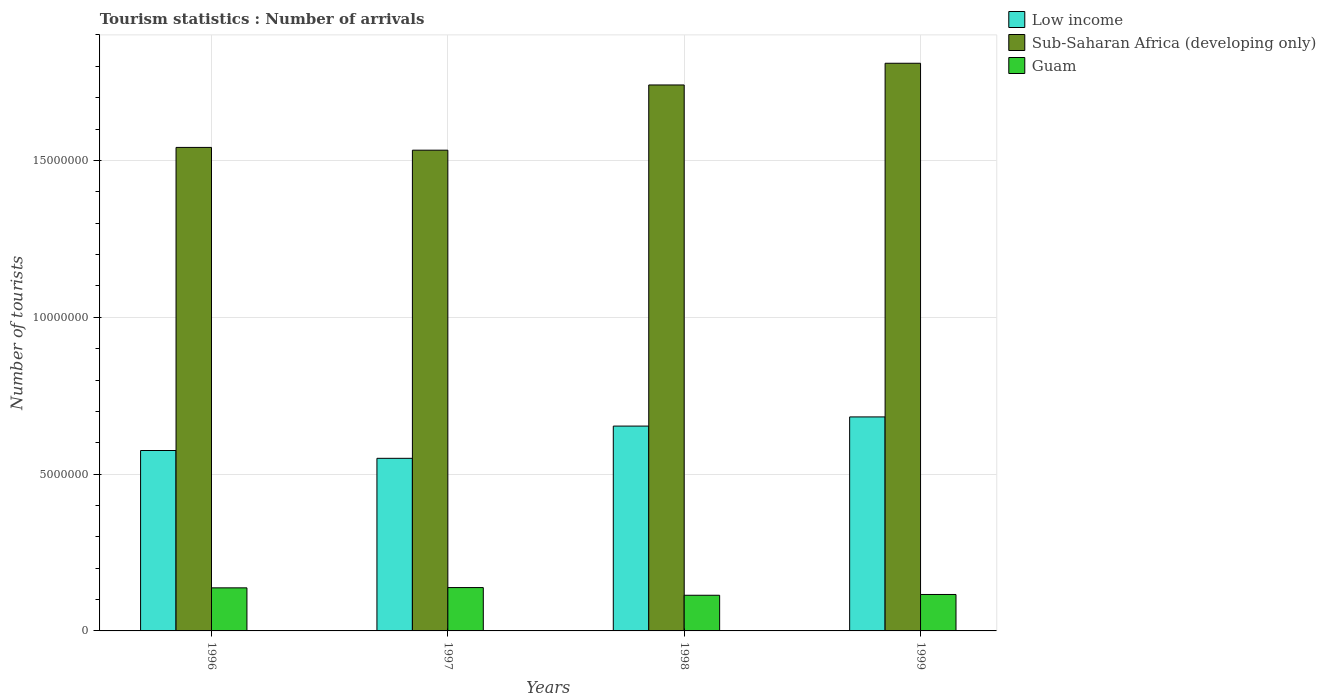How many groups of bars are there?
Make the answer very short. 4. Are the number of bars on each tick of the X-axis equal?
Provide a succinct answer. Yes. How many bars are there on the 3rd tick from the left?
Ensure brevity in your answer.  3. How many bars are there on the 4th tick from the right?
Your response must be concise. 3. What is the number of tourist arrivals in Guam in 1997?
Your answer should be compact. 1.38e+06. Across all years, what is the maximum number of tourist arrivals in Guam?
Your answer should be very brief. 1.38e+06. Across all years, what is the minimum number of tourist arrivals in Guam?
Offer a terse response. 1.14e+06. In which year was the number of tourist arrivals in Guam maximum?
Provide a succinct answer. 1997. In which year was the number of tourist arrivals in Low income minimum?
Your answer should be very brief. 1997. What is the total number of tourist arrivals in Low income in the graph?
Your response must be concise. 2.46e+07. What is the difference between the number of tourist arrivals in Guam in 1996 and that in 1999?
Keep it short and to the point. 2.11e+05. What is the difference between the number of tourist arrivals in Low income in 1997 and the number of tourist arrivals in Guam in 1996?
Your answer should be very brief. 4.13e+06. What is the average number of tourist arrivals in Guam per year?
Ensure brevity in your answer.  1.26e+06. In the year 1998, what is the difference between the number of tourist arrivals in Low income and number of tourist arrivals in Sub-Saharan Africa (developing only)?
Your response must be concise. -1.09e+07. In how many years, is the number of tourist arrivals in Low income greater than 16000000?
Your answer should be very brief. 0. What is the ratio of the number of tourist arrivals in Sub-Saharan Africa (developing only) in 1996 to that in 1999?
Make the answer very short. 0.85. Is the number of tourist arrivals in Guam in 1998 less than that in 1999?
Your response must be concise. Yes. Is the difference between the number of tourist arrivals in Low income in 1996 and 1997 greater than the difference between the number of tourist arrivals in Sub-Saharan Africa (developing only) in 1996 and 1997?
Give a very brief answer. Yes. What is the difference between the highest and the second highest number of tourist arrivals in Low income?
Make the answer very short. 2.92e+05. What is the difference between the highest and the lowest number of tourist arrivals in Sub-Saharan Africa (developing only)?
Your answer should be compact. 2.77e+06. What does the 3rd bar from the left in 1996 represents?
Provide a succinct answer. Guam. What does the 2nd bar from the right in 1997 represents?
Make the answer very short. Sub-Saharan Africa (developing only). Is it the case that in every year, the sum of the number of tourist arrivals in Guam and number of tourist arrivals in Sub-Saharan Africa (developing only) is greater than the number of tourist arrivals in Low income?
Offer a very short reply. Yes. How many bars are there?
Your answer should be compact. 12. Are all the bars in the graph horizontal?
Give a very brief answer. No. How many years are there in the graph?
Provide a succinct answer. 4. What is the difference between two consecutive major ticks on the Y-axis?
Your response must be concise. 5.00e+06. Does the graph contain grids?
Your response must be concise. Yes. How many legend labels are there?
Provide a short and direct response. 3. What is the title of the graph?
Offer a very short reply. Tourism statistics : Number of arrivals. Does "Hungary" appear as one of the legend labels in the graph?
Ensure brevity in your answer.  No. What is the label or title of the X-axis?
Provide a succinct answer. Years. What is the label or title of the Y-axis?
Make the answer very short. Number of tourists. What is the Number of tourists in Low income in 1996?
Offer a terse response. 5.75e+06. What is the Number of tourists of Sub-Saharan Africa (developing only) in 1996?
Make the answer very short. 1.54e+07. What is the Number of tourists in Guam in 1996?
Provide a short and direct response. 1.37e+06. What is the Number of tourists in Low income in 1997?
Offer a terse response. 5.50e+06. What is the Number of tourists of Sub-Saharan Africa (developing only) in 1997?
Provide a succinct answer. 1.53e+07. What is the Number of tourists of Guam in 1997?
Your answer should be compact. 1.38e+06. What is the Number of tourists of Low income in 1998?
Your response must be concise. 6.53e+06. What is the Number of tourists of Sub-Saharan Africa (developing only) in 1998?
Your response must be concise. 1.74e+07. What is the Number of tourists in Guam in 1998?
Your response must be concise. 1.14e+06. What is the Number of tourists of Low income in 1999?
Provide a succinct answer. 6.82e+06. What is the Number of tourists in Sub-Saharan Africa (developing only) in 1999?
Your answer should be very brief. 1.81e+07. What is the Number of tourists in Guam in 1999?
Make the answer very short. 1.16e+06. Across all years, what is the maximum Number of tourists of Low income?
Your answer should be very brief. 6.82e+06. Across all years, what is the maximum Number of tourists in Sub-Saharan Africa (developing only)?
Offer a very short reply. 1.81e+07. Across all years, what is the maximum Number of tourists in Guam?
Your response must be concise. 1.38e+06. Across all years, what is the minimum Number of tourists in Low income?
Ensure brevity in your answer.  5.50e+06. Across all years, what is the minimum Number of tourists of Sub-Saharan Africa (developing only)?
Provide a succinct answer. 1.53e+07. Across all years, what is the minimum Number of tourists in Guam?
Provide a short and direct response. 1.14e+06. What is the total Number of tourists of Low income in the graph?
Ensure brevity in your answer.  2.46e+07. What is the total Number of tourists in Sub-Saharan Africa (developing only) in the graph?
Your answer should be compact. 6.62e+07. What is the total Number of tourists of Guam in the graph?
Make the answer very short. 5.05e+06. What is the difference between the Number of tourists in Low income in 1996 and that in 1997?
Make the answer very short. 2.49e+05. What is the difference between the Number of tourists in Sub-Saharan Africa (developing only) in 1996 and that in 1997?
Offer a very short reply. 8.85e+04. What is the difference between the Number of tourists of Guam in 1996 and that in 1997?
Your response must be concise. -9000. What is the difference between the Number of tourists of Low income in 1996 and that in 1998?
Your answer should be compact. -7.79e+05. What is the difference between the Number of tourists in Sub-Saharan Africa (developing only) in 1996 and that in 1998?
Ensure brevity in your answer.  -1.99e+06. What is the difference between the Number of tourists of Guam in 1996 and that in 1998?
Provide a short and direct response. 2.36e+05. What is the difference between the Number of tourists of Low income in 1996 and that in 1999?
Offer a terse response. -1.07e+06. What is the difference between the Number of tourists of Sub-Saharan Africa (developing only) in 1996 and that in 1999?
Your response must be concise. -2.68e+06. What is the difference between the Number of tourists in Guam in 1996 and that in 1999?
Offer a terse response. 2.11e+05. What is the difference between the Number of tourists in Low income in 1997 and that in 1998?
Make the answer very short. -1.03e+06. What is the difference between the Number of tourists in Sub-Saharan Africa (developing only) in 1997 and that in 1998?
Ensure brevity in your answer.  -2.08e+06. What is the difference between the Number of tourists in Guam in 1997 and that in 1998?
Your answer should be very brief. 2.45e+05. What is the difference between the Number of tourists of Low income in 1997 and that in 1999?
Make the answer very short. -1.32e+06. What is the difference between the Number of tourists in Sub-Saharan Africa (developing only) in 1997 and that in 1999?
Provide a short and direct response. -2.77e+06. What is the difference between the Number of tourists of Low income in 1998 and that in 1999?
Offer a very short reply. -2.92e+05. What is the difference between the Number of tourists of Sub-Saharan Africa (developing only) in 1998 and that in 1999?
Ensure brevity in your answer.  -6.92e+05. What is the difference between the Number of tourists of Guam in 1998 and that in 1999?
Keep it short and to the point. -2.50e+04. What is the difference between the Number of tourists of Low income in 1996 and the Number of tourists of Sub-Saharan Africa (developing only) in 1997?
Provide a short and direct response. -9.57e+06. What is the difference between the Number of tourists in Low income in 1996 and the Number of tourists in Guam in 1997?
Your answer should be very brief. 4.37e+06. What is the difference between the Number of tourists in Sub-Saharan Africa (developing only) in 1996 and the Number of tourists in Guam in 1997?
Keep it short and to the point. 1.40e+07. What is the difference between the Number of tourists in Low income in 1996 and the Number of tourists in Sub-Saharan Africa (developing only) in 1998?
Your answer should be compact. -1.17e+07. What is the difference between the Number of tourists in Low income in 1996 and the Number of tourists in Guam in 1998?
Your answer should be compact. 4.62e+06. What is the difference between the Number of tourists in Sub-Saharan Africa (developing only) in 1996 and the Number of tourists in Guam in 1998?
Your answer should be compact. 1.43e+07. What is the difference between the Number of tourists of Low income in 1996 and the Number of tourists of Sub-Saharan Africa (developing only) in 1999?
Your response must be concise. -1.23e+07. What is the difference between the Number of tourists of Low income in 1996 and the Number of tourists of Guam in 1999?
Offer a very short reply. 4.59e+06. What is the difference between the Number of tourists of Sub-Saharan Africa (developing only) in 1996 and the Number of tourists of Guam in 1999?
Make the answer very short. 1.43e+07. What is the difference between the Number of tourists of Low income in 1997 and the Number of tourists of Sub-Saharan Africa (developing only) in 1998?
Offer a very short reply. -1.19e+07. What is the difference between the Number of tourists in Low income in 1997 and the Number of tourists in Guam in 1998?
Ensure brevity in your answer.  4.37e+06. What is the difference between the Number of tourists in Sub-Saharan Africa (developing only) in 1997 and the Number of tourists in Guam in 1998?
Offer a terse response. 1.42e+07. What is the difference between the Number of tourists of Low income in 1997 and the Number of tourists of Sub-Saharan Africa (developing only) in 1999?
Your answer should be very brief. -1.26e+07. What is the difference between the Number of tourists of Low income in 1997 and the Number of tourists of Guam in 1999?
Your response must be concise. 4.34e+06. What is the difference between the Number of tourists in Sub-Saharan Africa (developing only) in 1997 and the Number of tourists in Guam in 1999?
Offer a very short reply. 1.42e+07. What is the difference between the Number of tourists of Low income in 1998 and the Number of tourists of Sub-Saharan Africa (developing only) in 1999?
Keep it short and to the point. -1.16e+07. What is the difference between the Number of tourists of Low income in 1998 and the Number of tourists of Guam in 1999?
Make the answer very short. 5.37e+06. What is the difference between the Number of tourists of Sub-Saharan Africa (developing only) in 1998 and the Number of tourists of Guam in 1999?
Offer a terse response. 1.62e+07. What is the average Number of tourists in Low income per year?
Provide a succinct answer. 6.15e+06. What is the average Number of tourists in Sub-Saharan Africa (developing only) per year?
Provide a succinct answer. 1.66e+07. What is the average Number of tourists in Guam per year?
Provide a short and direct response. 1.26e+06. In the year 1996, what is the difference between the Number of tourists in Low income and Number of tourists in Sub-Saharan Africa (developing only)?
Your response must be concise. -9.66e+06. In the year 1996, what is the difference between the Number of tourists of Low income and Number of tourists of Guam?
Keep it short and to the point. 4.38e+06. In the year 1996, what is the difference between the Number of tourists in Sub-Saharan Africa (developing only) and Number of tourists in Guam?
Keep it short and to the point. 1.40e+07. In the year 1997, what is the difference between the Number of tourists of Low income and Number of tourists of Sub-Saharan Africa (developing only)?
Provide a succinct answer. -9.82e+06. In the year 1997, what is the difference between the Number of tourists of Low income and Number of tourists of Guam?
Give a very brief answer. 4.12e+06. In the year 1997, what is the difference between the Number of tourists in Sub-Saharan Africa (developing only) and Number of tourists in Guam?
Your answer should be compact. 1.39e+07. In the year 1998, what is the difference between the Number of tourists of Low income and Number of tourists of Sub-Saharan Africa (developing only)?
Provide a succinct answer. -1.09e+07. In the year 1998, what is the difference between the Number of tourists in Low income and Number of tourists in Guam?
Keep it short and to the point. 5.39e+06. In the year 1998, what is the difference between the Number of tourists of Sub-Saharan Africa (developing only) and Number of tourists of Guam?
Your answer should be compact. 1.63e+07. In the year 1999, what is the difference between the Number of tourists of Low income and Number of tourists of Sub-Saharan Africa (developing only)?
Provide a succinct answer. -1.13e+07. In the year 1999, what is the difference between the Number of tourists in Low income and Number of tourists in Guam?
Offer a terse response. 5.66e+06. In the year 1999, what is the difference between the Number of tourists of Sub-Saharan Africa (developing only) and Number of tourists of Guam?
Your answer should be very brief. 1.69e+07. What is the ratio of the Number of tourists of Low income in 1996 to that in 1997?
Your answer should be compact. 1.05. What is the ratio of the Number of tourists in Sub-Saharan Africa (developing only) in 1996 to that in 1997?
Provide a succinct answer. 1.01. What is the ratio of the Number of tourists of Guam in 1996 to that in 1997?
Your answer should be very brief. 0.99. What is the ratio of the Number of tourists in Low income in 1996 to that in 1998?
Your answer should be very brief. 0.88. What is the ratio of the Number of tourists in Sub-Saharan Africa (developing only) in 1996 to that in 1998?
Offer a very short reply. 0.89. What is the ratio of the Number of tourists in Guam in 1996 to that in 1998?
Offer a very short reply. 1.21. What is the ratio of the Number of tourists of Low income in 1996 to that in 1999?
Ensure brevity in your answer.  0.84. What is the ratio of the Number of tourists in Sub-Saharan Africa (developing only) in 1996 to that in 1999?
Your answer should be very brief. 0.85. What is the ratio of the Number of tourists in Guam in 1996 to that in 1999?
Ensure brevity in your answer.  1.18. What is the ratio of the Number of tourists of Low income in 1997 to that in 1998?
Provide a succinct answer. 0.84. What is the ratio of the Number of tourists of Sub-Saharan Africa (developing only) in 1997 to that in 1998?
Give a very brief answer. 0.88. What is the ratio of the Number of tourists in Guam in 1997 to that in 1998?
Your answer should be very brief. 1.22. What is the ratio of the Number of tourists of Low income in 1997 to that in 1999?
Keep it short and to the point. 0.81. What is the ratio of the Number of tourists in Sub-Saharan Africa (developing only) in 1997 to that in 1999?
Provide a short and direct response. 0.85. What is the ratio of the Number of tourists of Guam in 1997 to that in 1999?
Make the answer very short. 1.19. What is the ratio of the Number of tourists of Low income in 1998 to that in 1999?
Offer a very short reply. 0.96. What is the ratio of the Number of tourists in Sub-Saharan Africa (developing only) in 1998 to that in 1999?
Your response must be concise. 0.96. What is the ratio of the Number of tourists in Guam in 1998 to that in 1999?
Keep it short and to the point. 0.98. What is the difference between the highest and the second highest Number of tourists in Low income?
Offer a terse response. 2.92e+05. What is the difference between the highest and the second highest Number of tourists in Sub-Saharan Africa (developing only)?
Make the answer very short. 6.92e+05. What is the difference between the highest and the second highest Number of tourists in Guam?
Offer a terse response. 9000. What is the difference between the highest and the lowest Number of tourists in Low income?
Offer a terse response. 1.32e+06. What is the difference between the highest and the lowest Number of tourists in Sub-Saharan Africa (developing only)?
Provide a succinct answer. 2.77e+06. What is the difference between the highest and the lowest Number of tourists in Guam?
Your answer should be very brief. 2.45e+05. 